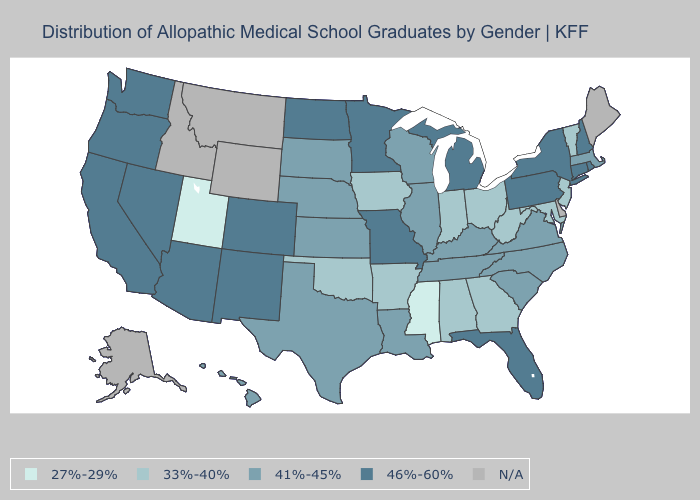Which states hav the highest value in the South?
Give a very brief answer. Florida. Which states have the lowest value in the USA?
Be succinct. Mississippi, Utah. Name the states that have a value in the range 41%-45%?
Concise answer only. Hawaii, Illinois, Kansas, Kentucky, Louisiana, Massachusetts, Nebraska, North Carolina, South Carolina, South Dakota, Tennessee, Texas, Virginia, Wisconsin. What is the value of Connecticut?
Short answer required. 46%-60%. What is the value of Iowa?
Answer briefly. 33%-40%. Does the map have missing data?
Write a very short answer. Yes. Does the first symbol in the legend represent the smallest category?
Keep it brief. Yes. Does Mississippi have the lowest value in the USA?
Be succinct. Yes. What is the value of Hawaii?
Short answer required. 41%-45%. Is the legend a continuous bar?
Write a very short answer. No. What is the highest value in the MidWest ?
Short answer required. 46%-60%. Name the states that have a value in the range N/A?
Be succinct. Alaska, Delaware, Idaho, Maine, Montana, Wyoming. What is the highest value in the Northeast ?
Be succinct. 46%-60%. What is the highest value in the USA?
Short answer required. 46%-60%. 